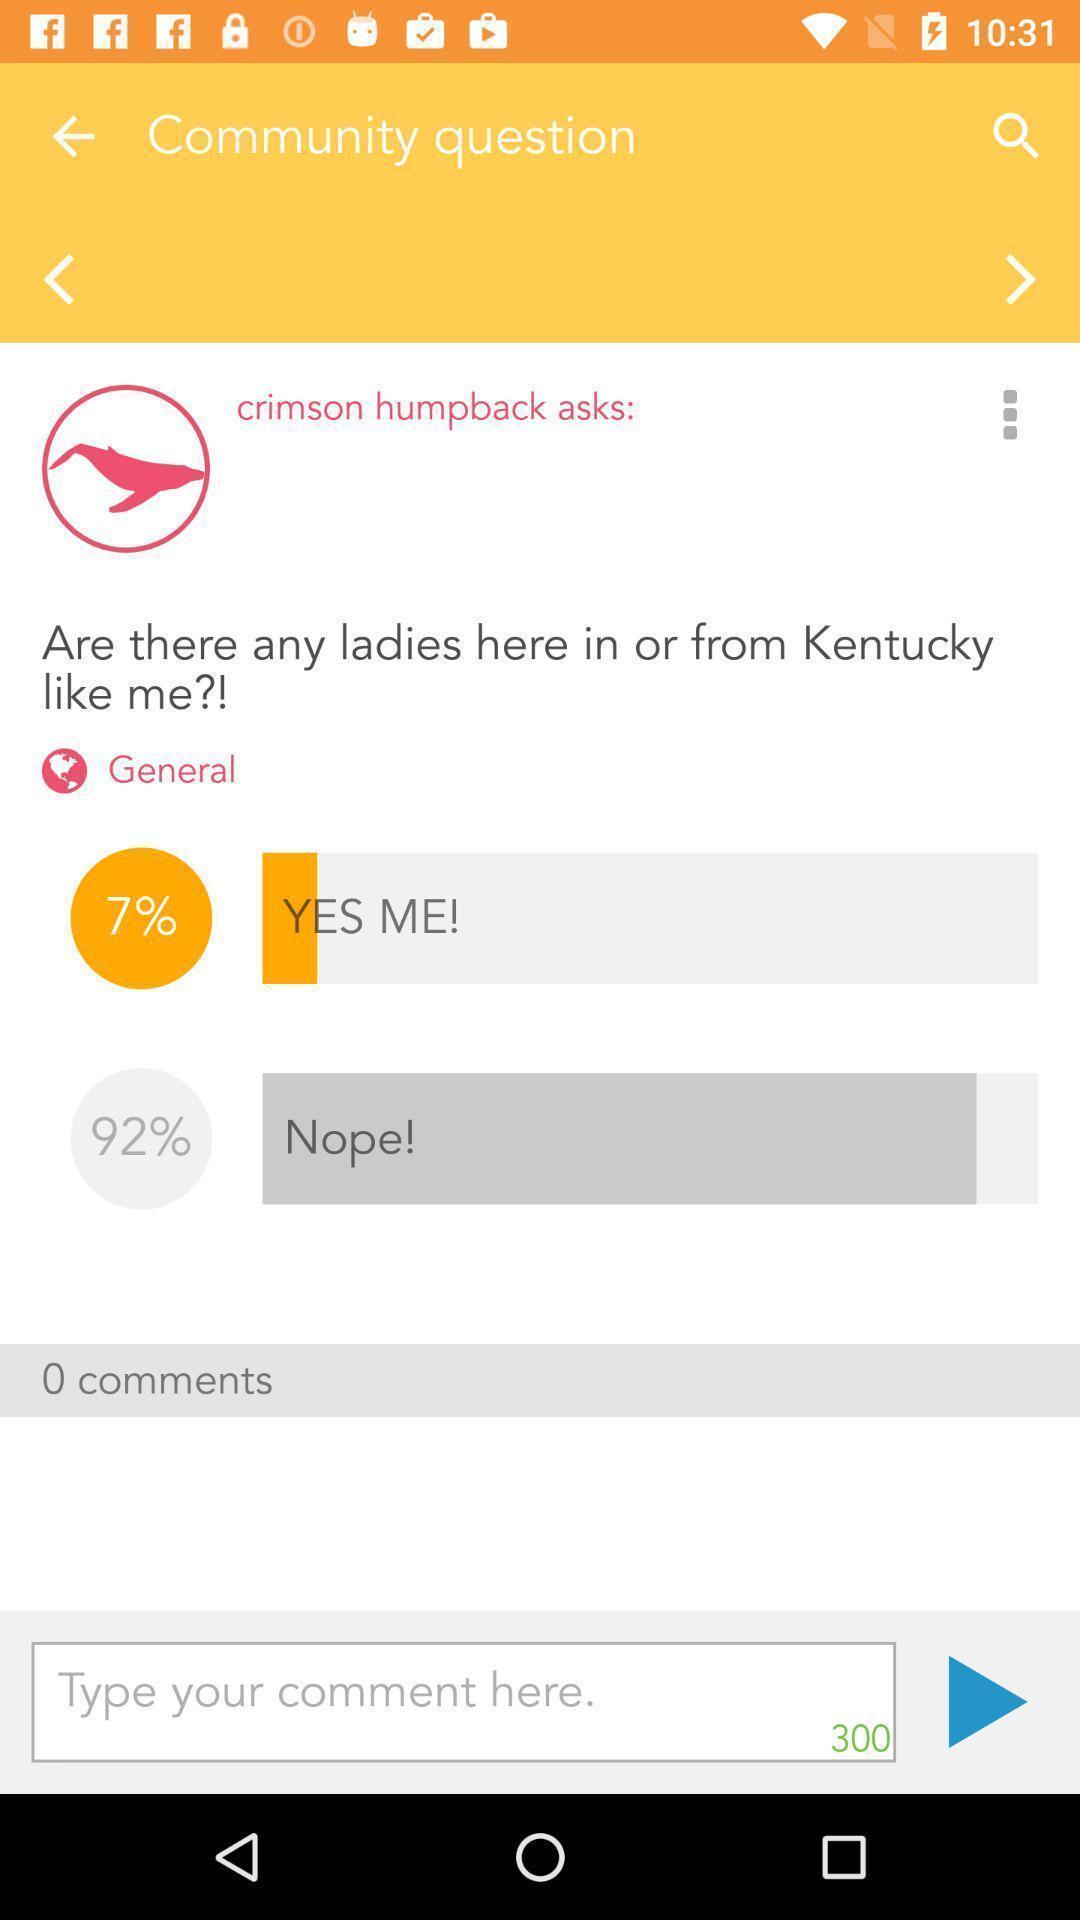Describe the content in this image. Screen showing comment page of a health app. 